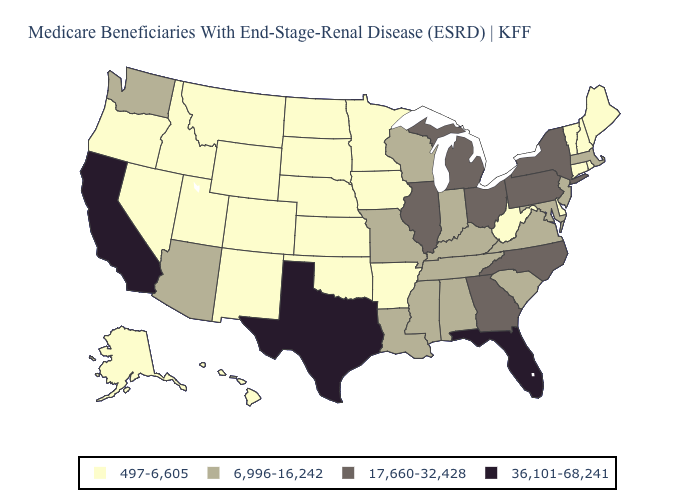Does South Dakota have the highest value in the USA?
Concise answer only. No. Name the states that have a value in the range 497-6,605?
Answer briefly. Alaska, Arkansas, Colorado, Connecticut, Delaware, Hawaii, Idaho, Iowa, Kansas, Maine, Minnesota, Montana, Nebraska, Nevada, New Hampshire, New Mexico, North Dakota, Oklahoma, Oregon, Rhode Island, South Dakota, Utah, Vermont, West Virginia, Wyoming. Name the states that have a value in the range 6,996-16,242?
Write a very short answer. Alabama, Arizona, Indiana, Kentucky, Louisiana, Maryland, Massachusetts, Mississippi, Missouri, New Jersey, South Carolina, Tennessee, Virginia, Washington, Wisconsin. Does Rhode Island have the lowest value in the Northeast?
Be succinct. Yes. What is the lowest value in the South?
Answer briefly. 497-6,605. Does South Dakota have a lower value than Nevada?
Write a very short answer. No. Name the states that have a value in the range 497-6,605?
Give a very brief answer. Alaska, Arkansas, Colorado, Connecticut, Delaware, Hawaii, Idaho, Iowa, Kansas, Maine, Minnesota, Montana, Nebraska, Nevada, New Hampshire, New Mexico, North Dakota, Oklahoma, Oregon, Rhode Island, South Dakota, Utah, Vermont, West Virginia, Wyoming. Is the legend a continuous bar?
Give a very brief answer. No. Among the states that border Texas , does Louisiana have the lowest value?
Answer briefly. No. What is the value of Vermont?
Give a very brief answer. 497-6,605. Name the states that have a value in the range 17,660-32,428?
Answer briefly. Georgia, Illinois, Michigan, New York, North Carolina, Ohio, Pennsylvania. What is the lowest value in the Northeast?
Quick response, please. 497-6,605. Name the states that have a value in the range 36,101-68,241?
Answer briefly. California, Florida, Texas. 